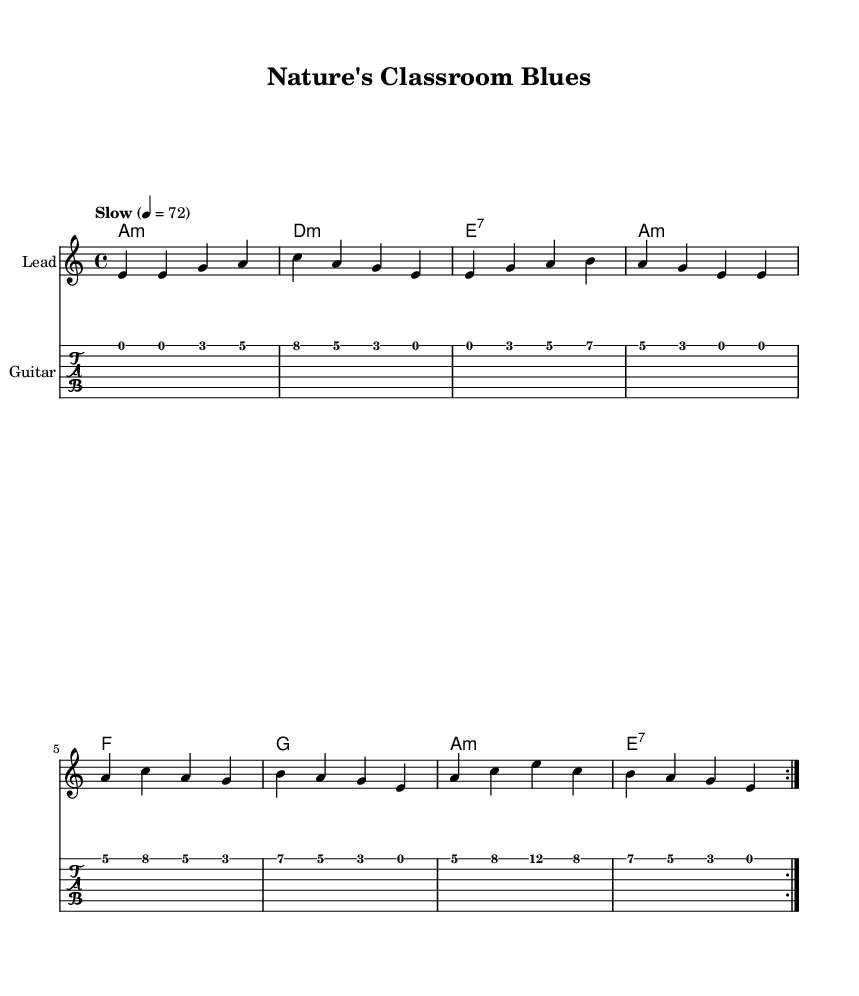What is the key signature of this music? The music is in the key of A minor, which has no sharps or flats in its key signature. This is determined by identifying the key indicated at the beginning of the piece.
Answer: A minor What is the time signature of this music? The time signature is 4/4, as indicated at the beginning of the sheet music. This means there are four beats in each measure, and the quarter note gets one beat.
Answer: 4/4 What is the tempo marking of this piece? The tempo marking is "Slow" with a metronome marking of 72 beats per minute, which indicates the speed at which the piece should be played. This is found in the macro notation above the piece.
Answer: Slow, 72 How many times is the melody repeated in the first section? The melody is repeated two times in the first section, as indicated by the \repeat volta 2 marking. This shows that the section before the repeat sign will be played twice.
Answer: 2 What is the first chord in the harmony? The first chord in the harmony is A minor, which is indicated by the chord name placed at the beginning of the music.
Answer: A minor What theme is reflected in the lyrics of this piece? The lyrics reflect themes of outdoor learning and nature's influence on education, as they describe growth and discovery beneath the trees. This thematic content is derived from analyzing the text set to the melody.
Answer: Outdoor learning Name one specific musical characteristic of Electric Blues present in this ballad. One characteristic is the use of a 12-bar structure, typical of blues music, although this specific piece has a simplified structure, the feeling and style remain bluesy. This can be inferred from the repetitive phrasing and typical blues chords.
Answer: 12-bar structure 